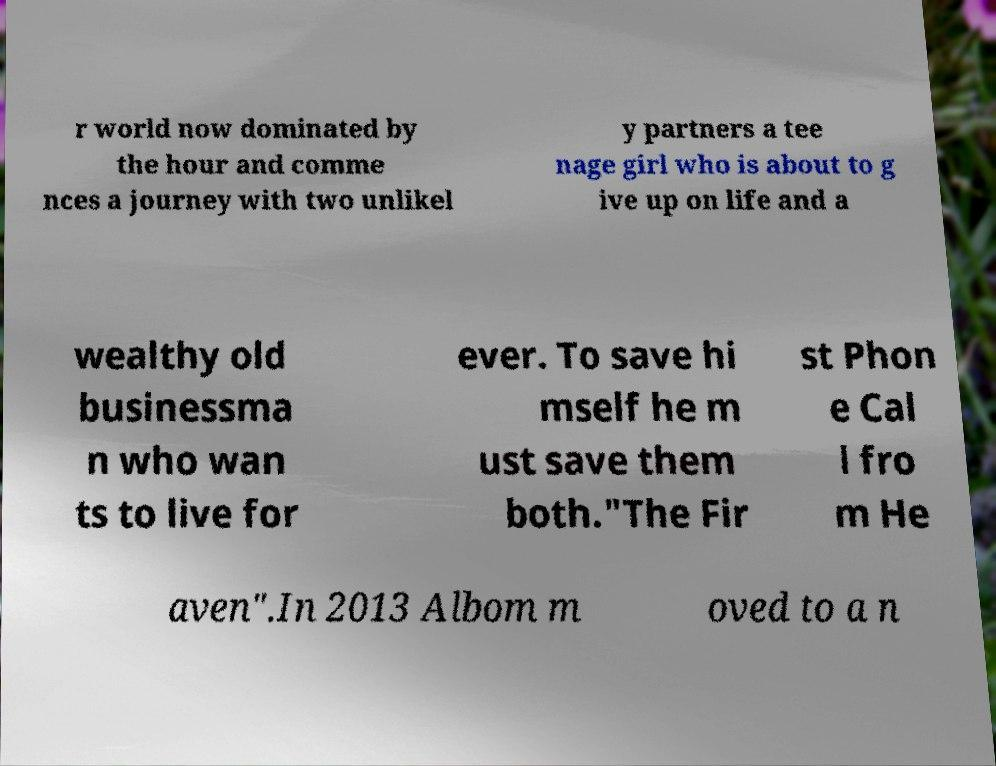Please identify and transcribe the text found in this image. r world now dominated by the hour and comme nces a journey with two unlikel y partners a tee nage girl who is about to g ive up on life and a wealthy old businessma n who wan ts to live for ever. To save hi mself he m ust save them both."The Fir st Phon e Cal l fro m He aven".In 2013 Albom m oved to a n 